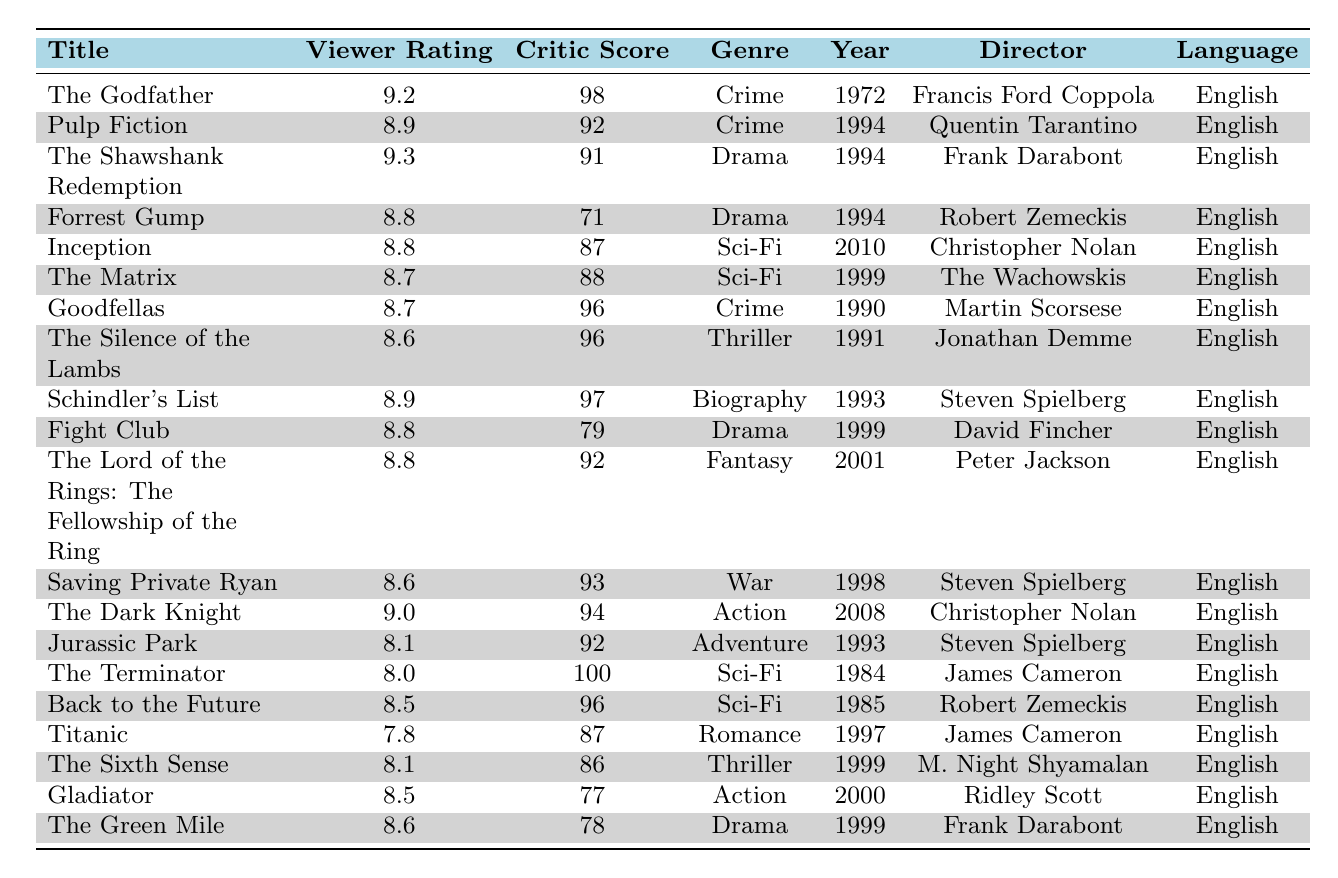What is the viewer rating of "The Godfather"? The table lists the viewer ratings for each film. For "The Godfather," the viewer rating is shown as 9.2.
Answer: 9.2 Who directed "Inception"? The director of each film is listed in the table. "Inception" is directed by Christopher Nolan.
Answer: Christopher Nolan What genre is "The Silence of the Lambs"? The table specifies the genre for each film. "The Silence of the Lambs" falls under the Thriller genre.
Answer: Thriller Which film has the highest critic score? By reviewing the critic scores in the table, "The Terminator" has the highest critic score of 100.
Answer: The Terminator What is the average viewer rating of the films listed? First, we sum the viewer ratings: (9.2 + 8.9 + 9.3 + 8.8 + 8.8 + 8.7 + 8.7 + 8.6 + 8.9 + 8.8 + 8.8 + 8.6 + 9.0 + 8.1 + 8.0 + 8.5 + 7.8 + 8.1 + 8.5 + 8.6) = 175.6. There are 20 films, so the average is 175.6/20 = 8.78.
Answer: 8.78 Is "Titanic" from the 1990s? Looking at the release year for "Titanic," which is 1997, confirms that it is indeed from the 1990s.
Answer: Yes Which film has a lower viewer rating: "Fight Club" or "The Green Mile"? The viewer ratings are 8.8 for "Fight Club" and 8.6 for "The Green Mile." Since 8.6 is less than 8.8, "The Green Mile" has the lower viewer rating.
Answer: The Green Mile What is the difference between the viewer rating of "The Dark Knight" and "Jurassic Park"? The viewer rating for "The Dark Knight" is 9.0, and for "Jurassic Park," it is 8.1. The difference is 9.0 - 8.1 = 0.9.
Answer: 0.9 Which film released in 1994 has a higher viewer rating: "Forrest Gump" or "Pulp Fiction"? "Forrest Gump" has a viewer rating of 8.8, while "Pulp Fiction" has 8.9. Comparing these, 8.9 > 8.8, so "Pulp Fiction" has the higher viewer rating.
Answer: Pulp Fiction Are there any Sci-Fi films in the top 20 that have a critic score of 90 or higher? "The Matrix" has a critic score of 88, "Inception" has 87, and "The Terminator" has 100, which is greater than 90. Thus, there is one Sci-Fi film ("The Terminator") with a score of 90 or higher.
Answer: Yes, "The Terminator" What is the total critic score for all films listed? We sum up the critic scores: (98 + 92 + 91 + 71 + 87 + 88 + 96 + 96 + 97 + 79 + 92 + 93 + 94 + 92 + 100 + 96 + 87 + 86 + 77 + 78) = 1745.
Answer: 1745 How many films directed by Steven Spielberg are in the list? "Schindler's List," "Saving Private Ryan," and "Jurassic Park" are the films directed by Steven Spielberg, totaling three films.
Answer: 3 Which film has a viewer rating below 8.0? The table shows the ratings, and "The Terminator" has a viewer rating of 8.0, which means no film has ratings below 8.0.
Answer: No film What is the median critic score of the films? To find the median, we must list the critic scores in order: (71, 77, 78, 79, 86, 87, 87, 88, 88, 91, 92, 92, 93, 94, 96, 96, 97, 98, 100). There are 20 scores, so the median will be the average of the 10th and 11th scores: (92 + 92) / 2 = 92.
Answer: 92 Which movie has a viewer rating closest to the average viewer rating? The average viewer rating is 8.78. The viewer ratings of "Pulp Fiction" (8.9) and "The Green Mile" (8.6) are closest. "Pulp Fiction" is the closest above and "The Green Mile" the closest below. Thus, "Pulp Fiction" is slightly closer.
Answer: Pulp Fiction 